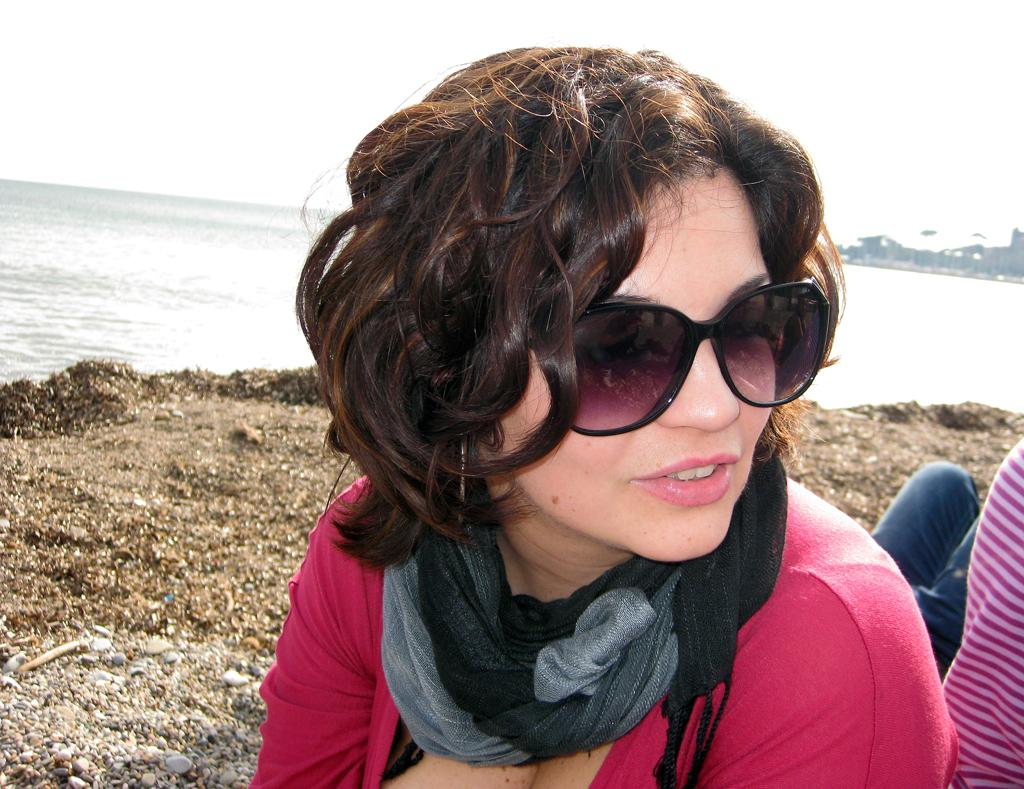Who or what is present in the image? There is a person in the image. Can you describe the person's appearance? The person is wearing glasses. What else can be seen in the image besides the person? There is water and the sky visible in the image. What type of honey can be seen dripping from the person's teeth in the image? There is no honey or teeth visible in the image, and therefore no such activity can be observed. 